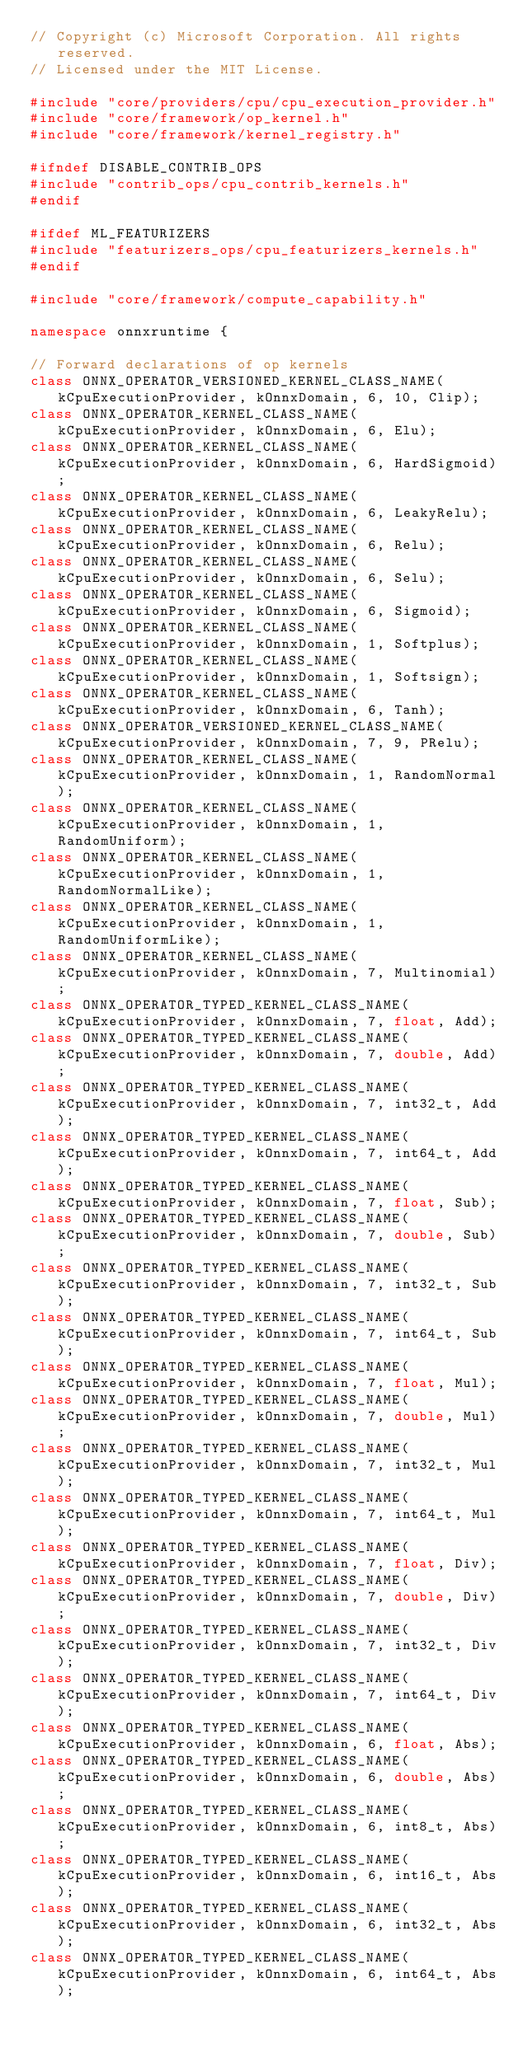<code> <loc_0><loc_0><loc_500><loc_500><_C++_>// Copyright (c) Microsoft Corporation. All rights reserved.
// Licensed under the MIT License.

#include "core/providers/cpu/cpu_execution_provider.h"
#include "core/framework/op_kernel.h"
#include "core/framework/kernel_registry.h"

#ifndef DISABLE_CONTRIB_OPS
#include "contrib_ops/cpu_contrib_kernels.h"
#endif

#ifdef ML_FEATURIZERS
#include "featurizers_ops/cpu_featurizers_kernels.h"
#endif

#include "core/framework/compute_capability.h"

namespace onnxruntime {

// Forward declarations of op kernels
class ONNX_OPERATOR_VERSIONED_KERNEL_CLASS_NAME(kCpuExecutionProvider, kOnnxDomain, 6, 10, Clip);
class ONNX_OPERATOR_KERNEL_CLASS_NAME(kCpuExecutionProvider, kOnnxDomain, 6, Elu);
class ONNX_OPERATOR_KERNEL_CLASS_NAME(kCpuExecutionProvider, kOnnxDomain, 6, HardSigmoid);
class ONNX_OPERATOR_KERNEL_CLASS_NAME(kCpuExecutionProvider, kOnnxDomain, 6, LeakyRelu);
class ONNX_OPERATOR_KERNEL_CLASS_NAME(kCpuExecutionProvider, kOnnxDomain, 6, Relu);
class ONNX_OPERATOR_KERNEL_CLASS_NAME(kCpuExecutionProvider, kOnnxDomain, 6, Selu);
class ONNX_OPERATOR_KERNEL_CLASS_NAME(kCpuExecutionProvider, kOnnxDomain, 6, Sigmoid);
class ONNX_OPERATOR_KERNEL_CLASS_NAME(kCpuExecutionProvider, kOnnxDomain, 1, Softplus);
class ONNX_OPERATOR_KERNEL_CLASS_NAME(kCpuExecutionProvider, kOnnxDomain, 1, Softsign);
class ONNX_OPERATOR_KERNEL_CLASS_NAME(kCpuExecutionProvider, kOnnxDomain, 6, Tanh);
class ONNX_OPERATOR_VERSIONED_KERNEL_CLASS_NAME(kCpuExecutionProvider, kOnnxDomain, 7, 9, PRelu);
class ONNX_OPERATOR_KERNEL_CLASS_NAME(kCpuExecutionProvider, kOnnxDomain, 1, RandomNormal);
class ONNX_OPERATOR_KERNEL_CLASS_NAME(kCpuExecutionProvider, kOnnxDomain, 1, RandomUniform);
class ONNX_OPERATOR_KERNEL_CLASS_NAME(kCpuExecutionProvider, kOnnxDomain, 1, RandomNormalLike);
class ONNX_OPERATOR_KERNEL_CLASS_NAME(kCpuExecutionProvider, kOnnxDomain, 1, RandomUniformLike);
class ONNX_OPERATOR_KERNEL_CLASS_NAME(kCpuExecutionProvider, kOnnxDomain, 7, Multinomial);
class ONNX_OPERATOR_TYPED_KERNEL_CLASS_NAME(kCpuExecutionProvider, kOnnxDomain, 7, float, Add);
class ONNX_OPERATOR_TYPED_KERNEL_CLASS_NAME(kCpuExecutionProvider, kOnnxDomain, 7, double, Add);
class ONNX_OPERATOR_TYPED_KERNEL_CLASS_NAME(kCpuExecutionProvider, kOnnxDomain, 7, int32_t, Add);
class ONNX_OPERATOR_TYPED_KERNEL_CLASS_NAME(kCpuExecutionProvider, kOnnxDomain, 7, int64_t, Add);
class ONNX_OPERATOR_TYPED_KERNEL_CLASS_NAME(kCpuExecutionProvider, kOnnxDomain, 7, float, Sub);
class ONNX_OPERATOR_TYPED_KERNEL_CLASS_NAME(kCpuExecutionProvider, kOnnxDomain, 7, double, Sub);
class ONNX_OPERATOR_TYPED_KERNEL_CLASS_NAME(kCpuExecutionProvider, kOnnxDomain, 7, int32_t, Sub);
class ONNX_OPERATOR_TYPED_KERNEL_CLASS_NAME(kCpuExecutionProvider, kOnnxDomain, 7, int64_t, Sub);
class ONNX_OPERATOR_TYPED_KERNEL_CLASS_NAME(kCpuExecutionProvider, kOnnxDomain, 7, float, Mul);
class ONNX_OPERATOR_TYPED_KERNEL_CLASS_NAME(kCpuExecutionProvider, kOnnxDomain, 7, double, Mul);
class ONNX_OPERATOR_TYPED_KERNEL_CLASS_NAME(kCpuExecutionProvider, kOnnxDomain, 7, int32_t, Mul);
class ONNX_OPERATOR_TYPED_KERNEL_CLASS_NAME(kCpuExecutionProvider, kOnnxDomain, 7, int64_t, Mul);
class ONNX_OPERATOR_TYPED_KERNEL_CLASS_NAME(kCpuExecutionProvider, kOnnxDomain, 7, float, Div);
class ONNX_OPERATOR_TYPED_KERNEL_CLASS_NAME(kCpuExecutionProvider, kOnnxDomain, 7, double, Div);
class ONNX_OPERATOR_TYPED_KERNEL_CLASS_NAME(kCpuExecutionProvider, kOnnxDomain, 7, int32_t, Div);
class ONNX_OPERATOR_TYPED_KERNEL_CLASS_NAME(kCpuExecutionProvider, kOnnxDomain, 7, int64_t, Div);
class ONNX_OPERATOR_TYPED_KERNEL_CLASS_NAME(kCpuExecutionProvider, kOnnxDomain, 6, float, Abs);
class ONNX_OPERATOR_TYPED_KERNEL_CLASS_NAME(kCpuExecutionProvider, kOnnxDomain, 6, double, Abs);
class ONNX_OPERATOR_TYPED_KERNEL_CLASS_NAME(kCpuExecutionProvider, kOnnxDomain, 6, int8_t, Abs);
class ONNX_OPERATOR_TYPED_KERNEL_CLASS_NAME(kCpuExecutionProvider, kOnnxDomain, 6, int16_t, Abs);
class ONNX_OPERATOR_TYPED_KERNEL_CLASS_NAME(kCpuExecutionProvider, kOnnxDomain, 6, int32_t, Abs);
class ONNX_OPERATOR_TYPED_KERNEL_CLASS_NAME(kCpuExecutionProvider, kOnnxDomain, 6, int64_t, Abs);</code> 